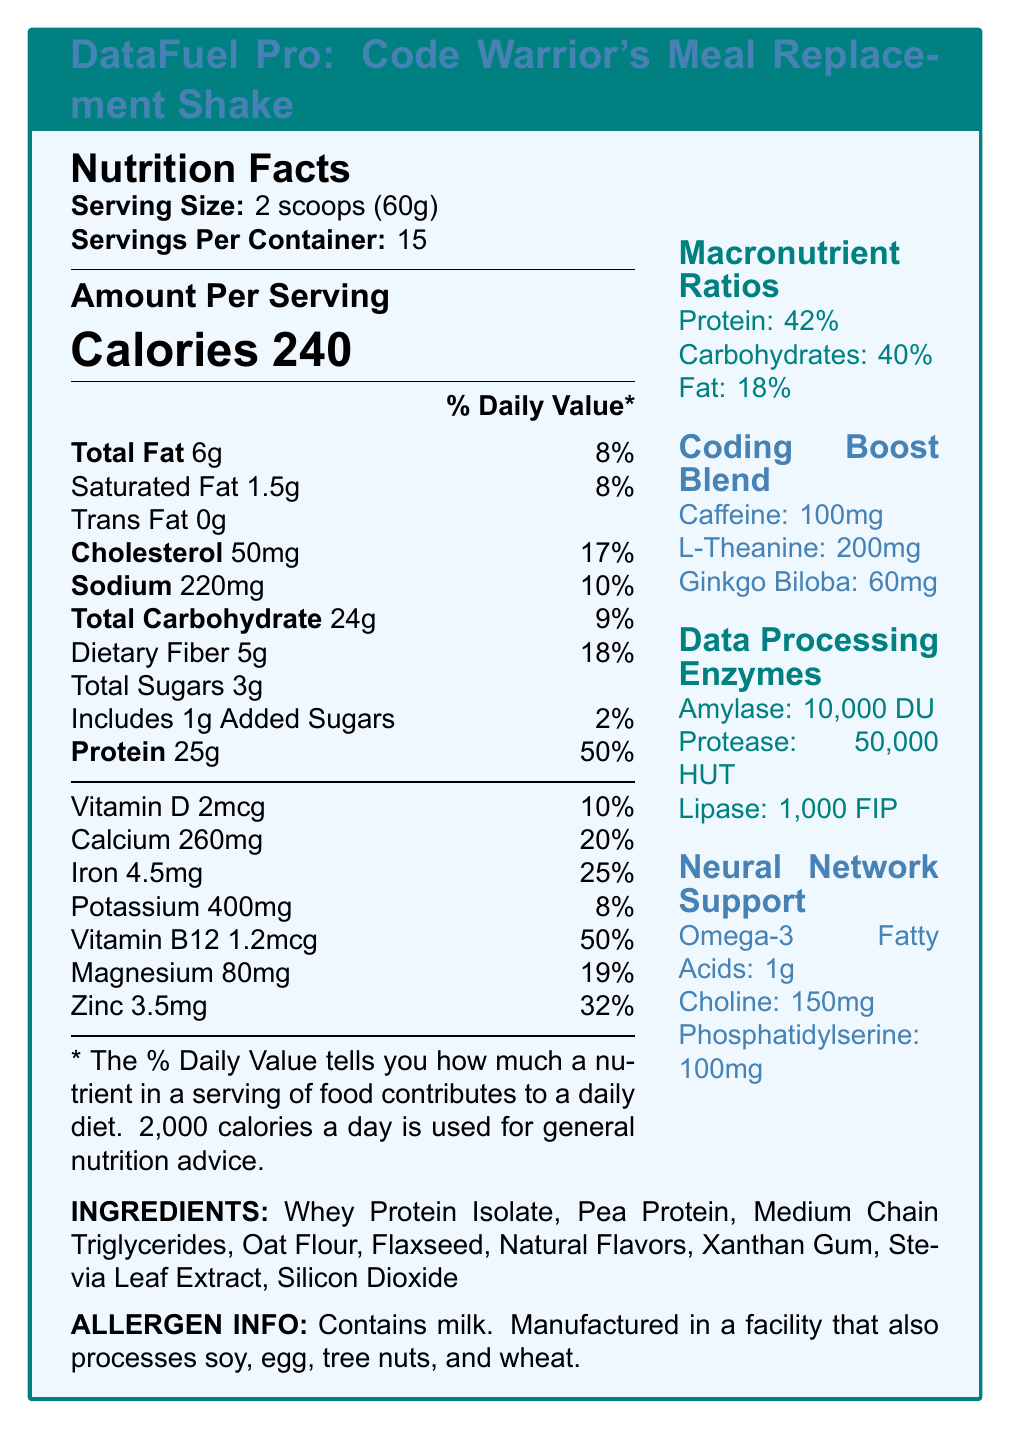what is the serving size of DataFuel Pro? The document mentions the serving size as "2 scoops (60g)" under the Nutrition Facts section.
Answer: 2 scoops (60g) what is the amount of protein per serving? The document indicates that there are 25g of protein per serving in the Amount Per Serving section.
Answer: 25g how many calories are in one serving? The Calories section under Amount Per Serving mentions that one serving contains 240 calories.
Answer: 240 What is the percentage daily value of dietary fiber in one serving? Under Total Carbohydrate, it lists Dietary Fiber with a daily value percentage of 18%.
Answer: 18% how much caffeine is in the Coding Boost Blend? In the Coding Boost Blend section, it states that there is 100mg of caffeine.
Answer: 100mg What is the daily value percentage of calcium in one serving? The Calcium section under daily values shows a percentage of 20%.
Answer: 20% how many servings are there per container? The document mentions "Servings Per Container: 15" in the Nutrition Facts section.
Answer: 15 what allergens are present in DataFuel Pro? According to the Allergen Info section, the product contains milk.
Answer: Milk how much cholesterol is in one serving? The Amount Per Serving section lists 50mg of cholesterol.
Answer: 50mg how much sodium is in one serving? The Amount Per Serving section lists 220mg of sodium.
Answer: 220mg how much iron does one serving provide? The daily value for iron is listed as 4.5mg.
Answer: 4.5mg which of the following is NOT an ingredient in DataFuel Pro? A. Whey Protein Isolate B. Soy Protein C. Pea Protein D. Oat Flour The ingredients list does not mention Soy Protein; it includes Whey Protein Isolate, Pea Protein, and Oat Flour.
Answer: B what are the macronutrient ratios in DataFuel Pro? A. Protein: 40%, Carbohydrates: 42%, Fat: 18% B. Protein: 42%, Carbohydrates: 40%, Fat: 18% C. Protein: 42%, Carbohydrates: 30%, Fat: 28% D. Protein: 30%, Carbohydrates: 42%, Fat: 28% The Macronutrient Ratios section lists Protein: 42%, Carbohydrates: 40%, and Fat: 18%.
Answer: B does DataFuel Pro contain any trans fats? The Trans Fat section under Amount Per Serving lists 0g.
Answer: No Summary: Describe the main information provided in the document. The main information includes the nutrition facts, specific macronutrient ratios, ingredients, and additional features like coding boost blend, which are all detailed to inform about the product's nutritional profile and benefits.
Answer: The document provides detailed nutritional information about DataFuel Pro: Code Warrior's Meal Replacement Shake. It lists the serving size, number of servings per container, the amount of calories, fats, cholesterol, sodium, carbohydrates, dietary fiber, sugars, and protein per serving along with their respective daily values. It mentions additional vitamins and minerals, macronutrient ratios, a coding boost blend, data processing enzymes, and neural network support components. The ingredients and allergen information are also provided. what is the percentage daily value of saturated fat? The Saturated Fat section under Total Fat shows a daily value of 8%.
Answer: 8% how much L-Theanine is included in the Coding Boost Blend? The Coding Boost Blend mentions 200mg of L-Theanine.
Answer: 200mg can you determine the manufacturing facility's other processed items based on the document? The allergen information states that the product is manufactured in a facility that also processes soy, egg, tree nuts, and wheat.
Answer: Yes is the amount of cholesterol more or less than the amount of sodium per serving? The document lists 50mg of cholesterol and 220mg of sodium per serving, so cholesterol is less than sodium.
Answer: Less what is the source of sweetness in DataFuel Pro? The ingredients list mentions Stevia Leaf Extract as a sweetener.
Answer: Stevia Leaf Extract what is the daily value percentage for potassium? The Potassium section under vitamins and minerals lists a daily value of 8%.
Answer: 8% how much choline is included in Neural Network Support? Under Neural Network Support, it mentions 150mg of choline.
Answer: 150mg are there any added sugars in DataFuel Pro? The document lists 1g of added sugars with a daily value of 2%.
Answer: Yes What is the percentage of protein in the macronutrient ratios? The Macronutrient Ratios section lists protein at 42%.
Answer: 42% which enzyme is not part of the Data Processing Enzymes? A. Amylase B. Protease C. Lipase D. Lactase The document lists Amylase, Protease, and Lipase under Data Processing Enzymes; Lactase is not mentioned.
Answer: D is vitamin D content higher than iron content? The document lists 2mcg of Vitamin D and 4.5mg of Iron, so iron content is higher.
Answer: No 